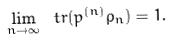<formula> <loc_0><loc_0><loc_500><loc_500>\lim _ { n \rightarrow \infty } \ t r ( p ^ { ( n ) } \rho _ { n } ) = 1 .</formula> 